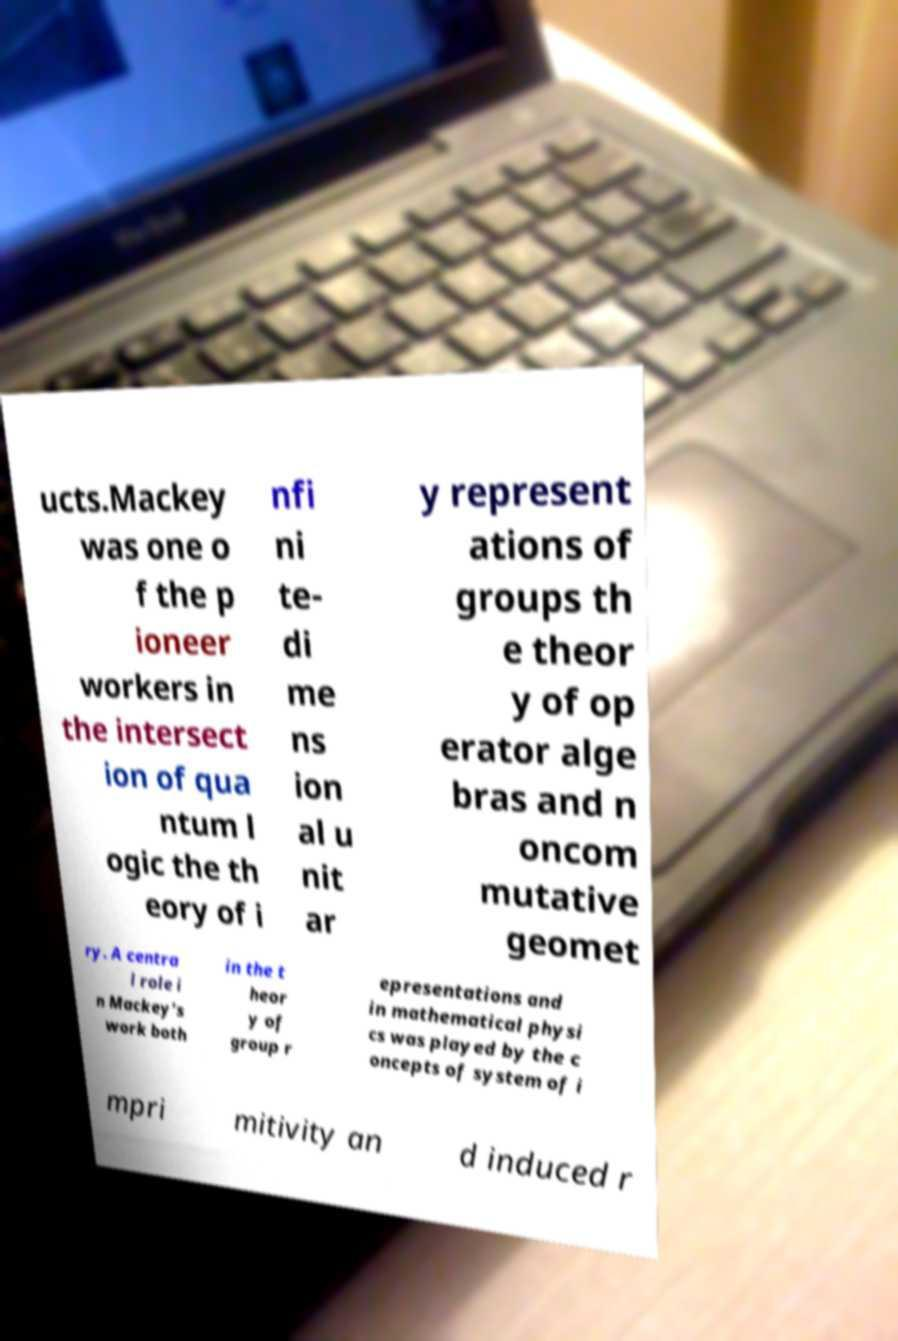What messages or text are displayed in this image? I need them in a readable, typed format. ucts.Mackey was one o f the p ioneer workers in the intersect ion of qua ntum l ogic the th eory of i nfi ni te- di me ns ion al u nit ar y represent ations of groups th e theor y of op erator alge bras and n oncom mutative geomet ry. A centra l role i n Mackey's work both in the t heor y of group r epresentations and in mathematical physi cs was played by the c oncepts of system of i mpri mitivity an d induced r 